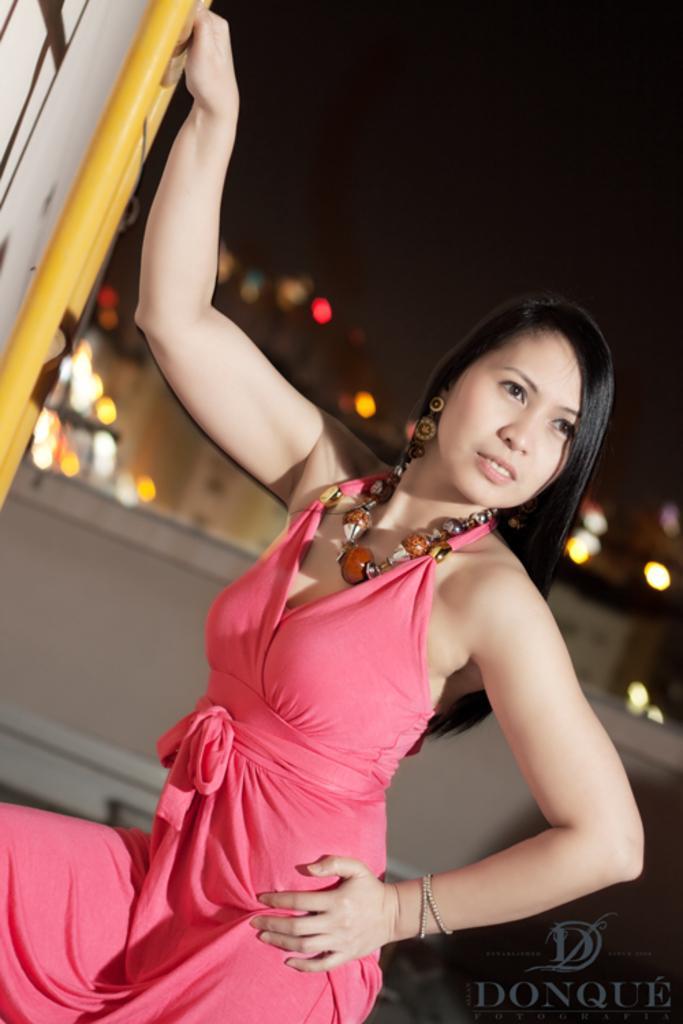Can you describe this image briefly? In this image I can see a woman. The woman is wearing pink color dress and a necklace. The background of the image is blurred. 